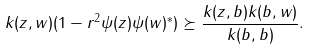<formula> <loc_0><loc_0><loc_500><loc_500>k ( z , w ) ( 1 - r ^ { 2 } \psi ( z ) \psi ( w ) ^ { * } ) \succeq \frac { k ( z , b ) k ( b , w ) } { k ( b , b ) } .</formula> 